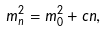<formula> <loc_0><loc_0><loc_500><loc_500>m _ { n } ^ { 2 } = m _ { 0 } ^ { 2 } + c n ,</formula> 